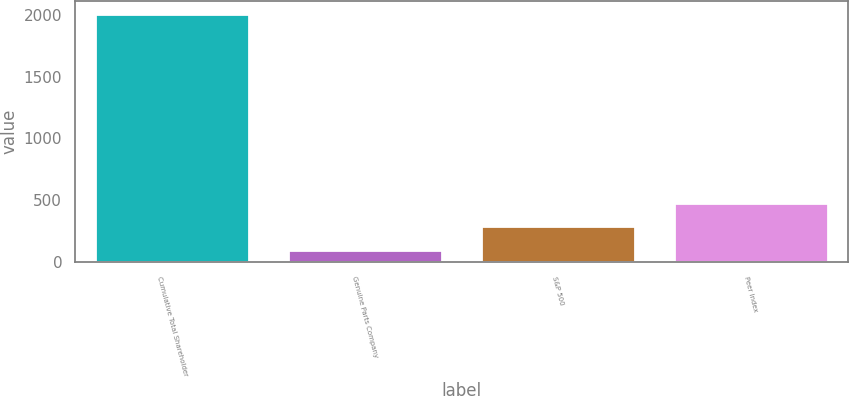Convert chart to OTSL. <chart><loc_0><loc_0><loc_500><loc_500><bar_chart><fcel>Cumulative Total Shareholder<fcel>Genuine Parts Company<fcel>S&P 500<fcel>Peer Index<nl><fcel>2010<fcel>100<fcel>291<fcel>482<nl></chart> 